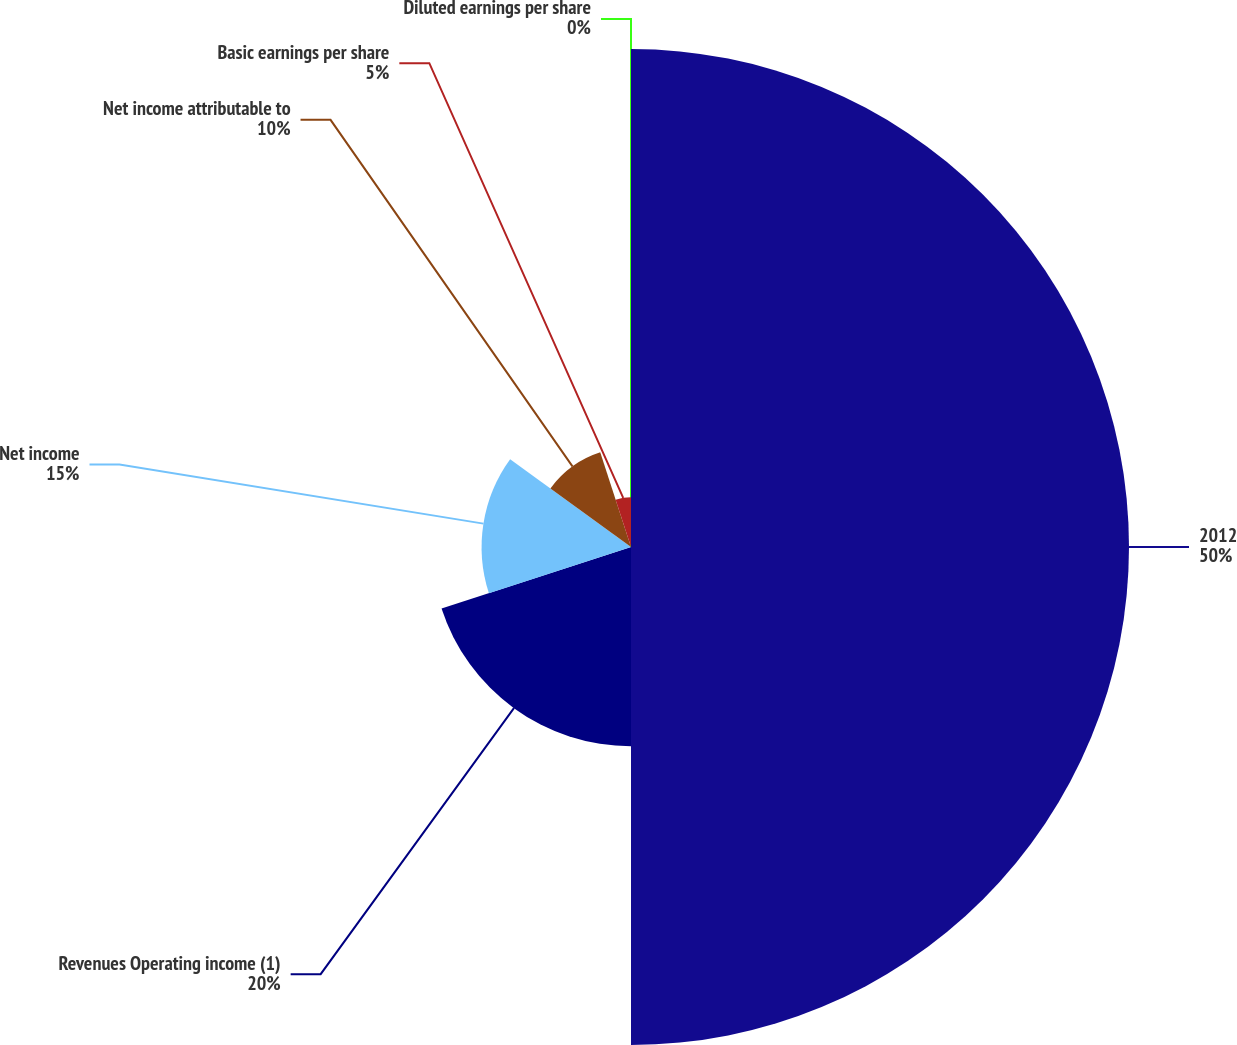Convert chart to OTSL. <chart><loc_0><loc_0><loc_500><loc_500><pie_chart><fcel>2012<fcel>Revenues Operating income (1)<fcel>Net income<fcel>Net income attributable to<fcel>Basic earnings per share<fcel>Diluted earnings per share<nl><fcel>50.0%<fcel>20.0%<fcel>15.0%<fcel>10.0%<fcel>5.0%<fcel>0.0%<nl></chart> 